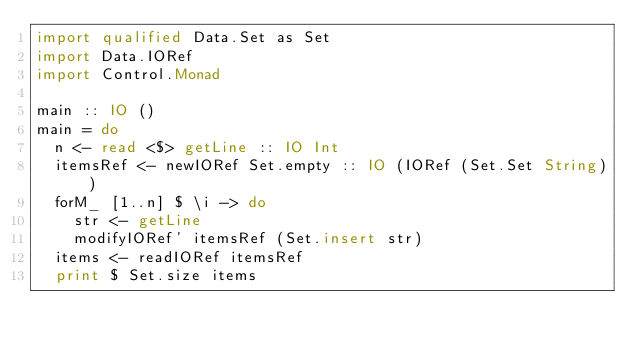Convert code to text. <code><loc_0><loc_0><loc_500><loc_500><_Haskell_>import qualified Data.Set as Set
import Data.IORef
import Control.Monad

main :: IO ()
main = do
  n <- read <$> getLine :: IO Int
  itemsRef <- newIORef Set.empty :: IO (IORef (Set.Set String))
  forM_ [1..n] $ \i -> do
    str <- getLine
    modifyIORef' itemsRef (Set.insert str)
  items <- readIORef itemsRef
  print $ Set.size items
</code> 